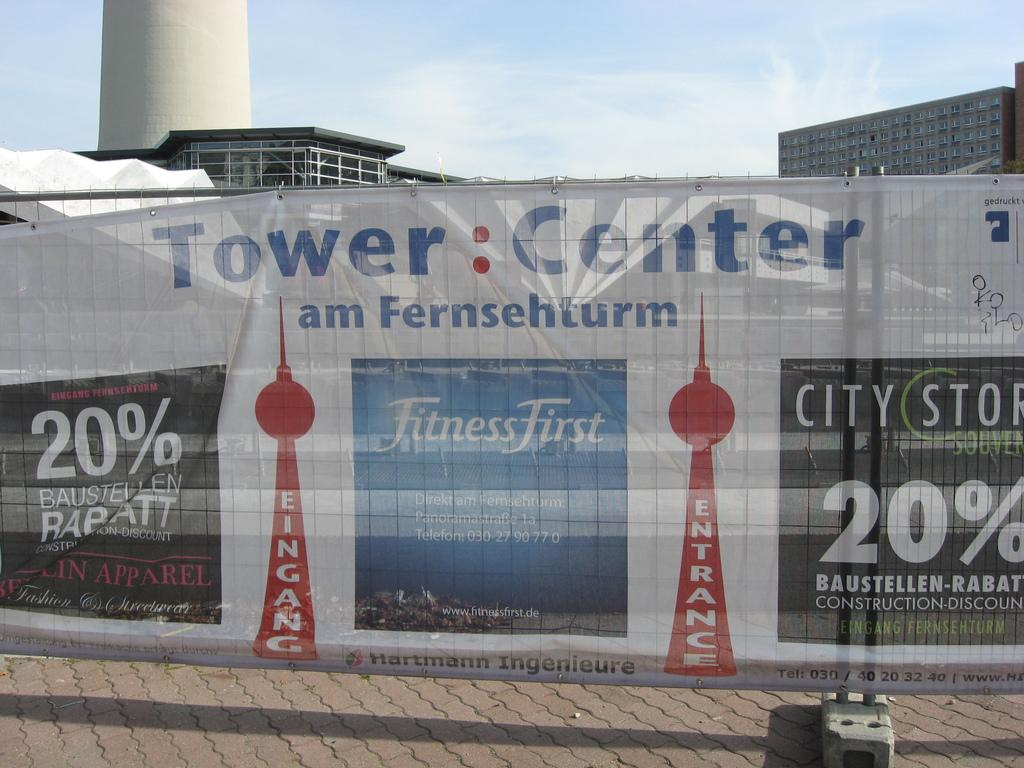What is the main object in the foreground of the image? There is a banner in the image. What can be read on the banner? Text is printed on the banner. What type of structures can be seen in the background of the image? There are buildings and a tower in the background of the image. What is visible above the buildings and tower? The sky is visible in the background of the image. What type of cup is being used to treat the disease in the image? There is no cup or disease present in the image; it features a banner with text and a background with buildings, a tower, and the sky. Can you tell me the breed of the cat that is sitting on the banner? There is no cat present in the image; it only features a banner with text and a background with buildings, a tower, and the sky. 